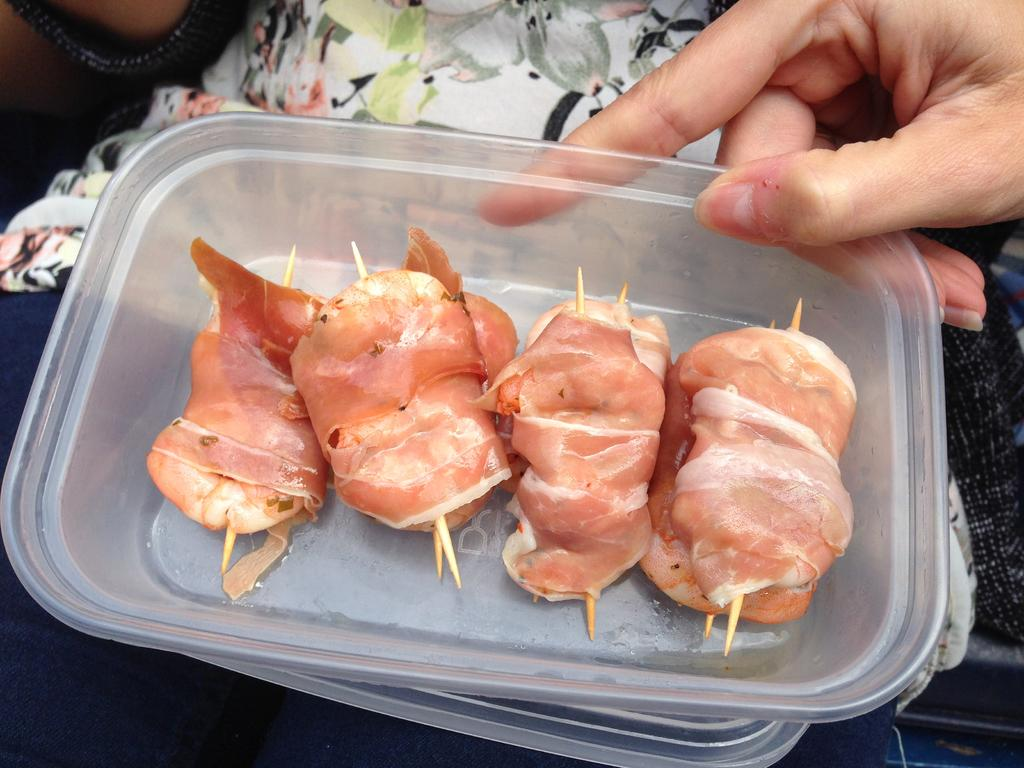What object is in the image that can hold items? There is a plastic box in the image that can hold items. What type of items are inside the plastic box? There are food items in the plastic box. Who is holding the plastic box in the image? There is a person holding the plastic box in the image. What musical instrument is being played by the person holding the plastic box in the image? There is no musical instrument being played by the person holding the plastic box in the image. 